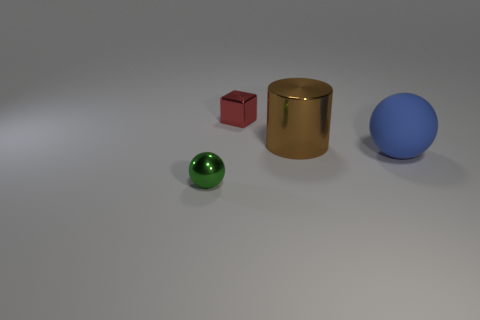Add 4 small red shiny spheres. How many objects exist? 8 Subtract all blocks. How many objects are left? 3 Add 4 large red metal balls. How many large red metal balls exist? 4 Subtract 0 blue cylinders. How many objects are left? 4 Subtract all rubber things. Subtract all brown things. How many objects are left? 2 Add 2 cubes. How many cubes are left? 3 